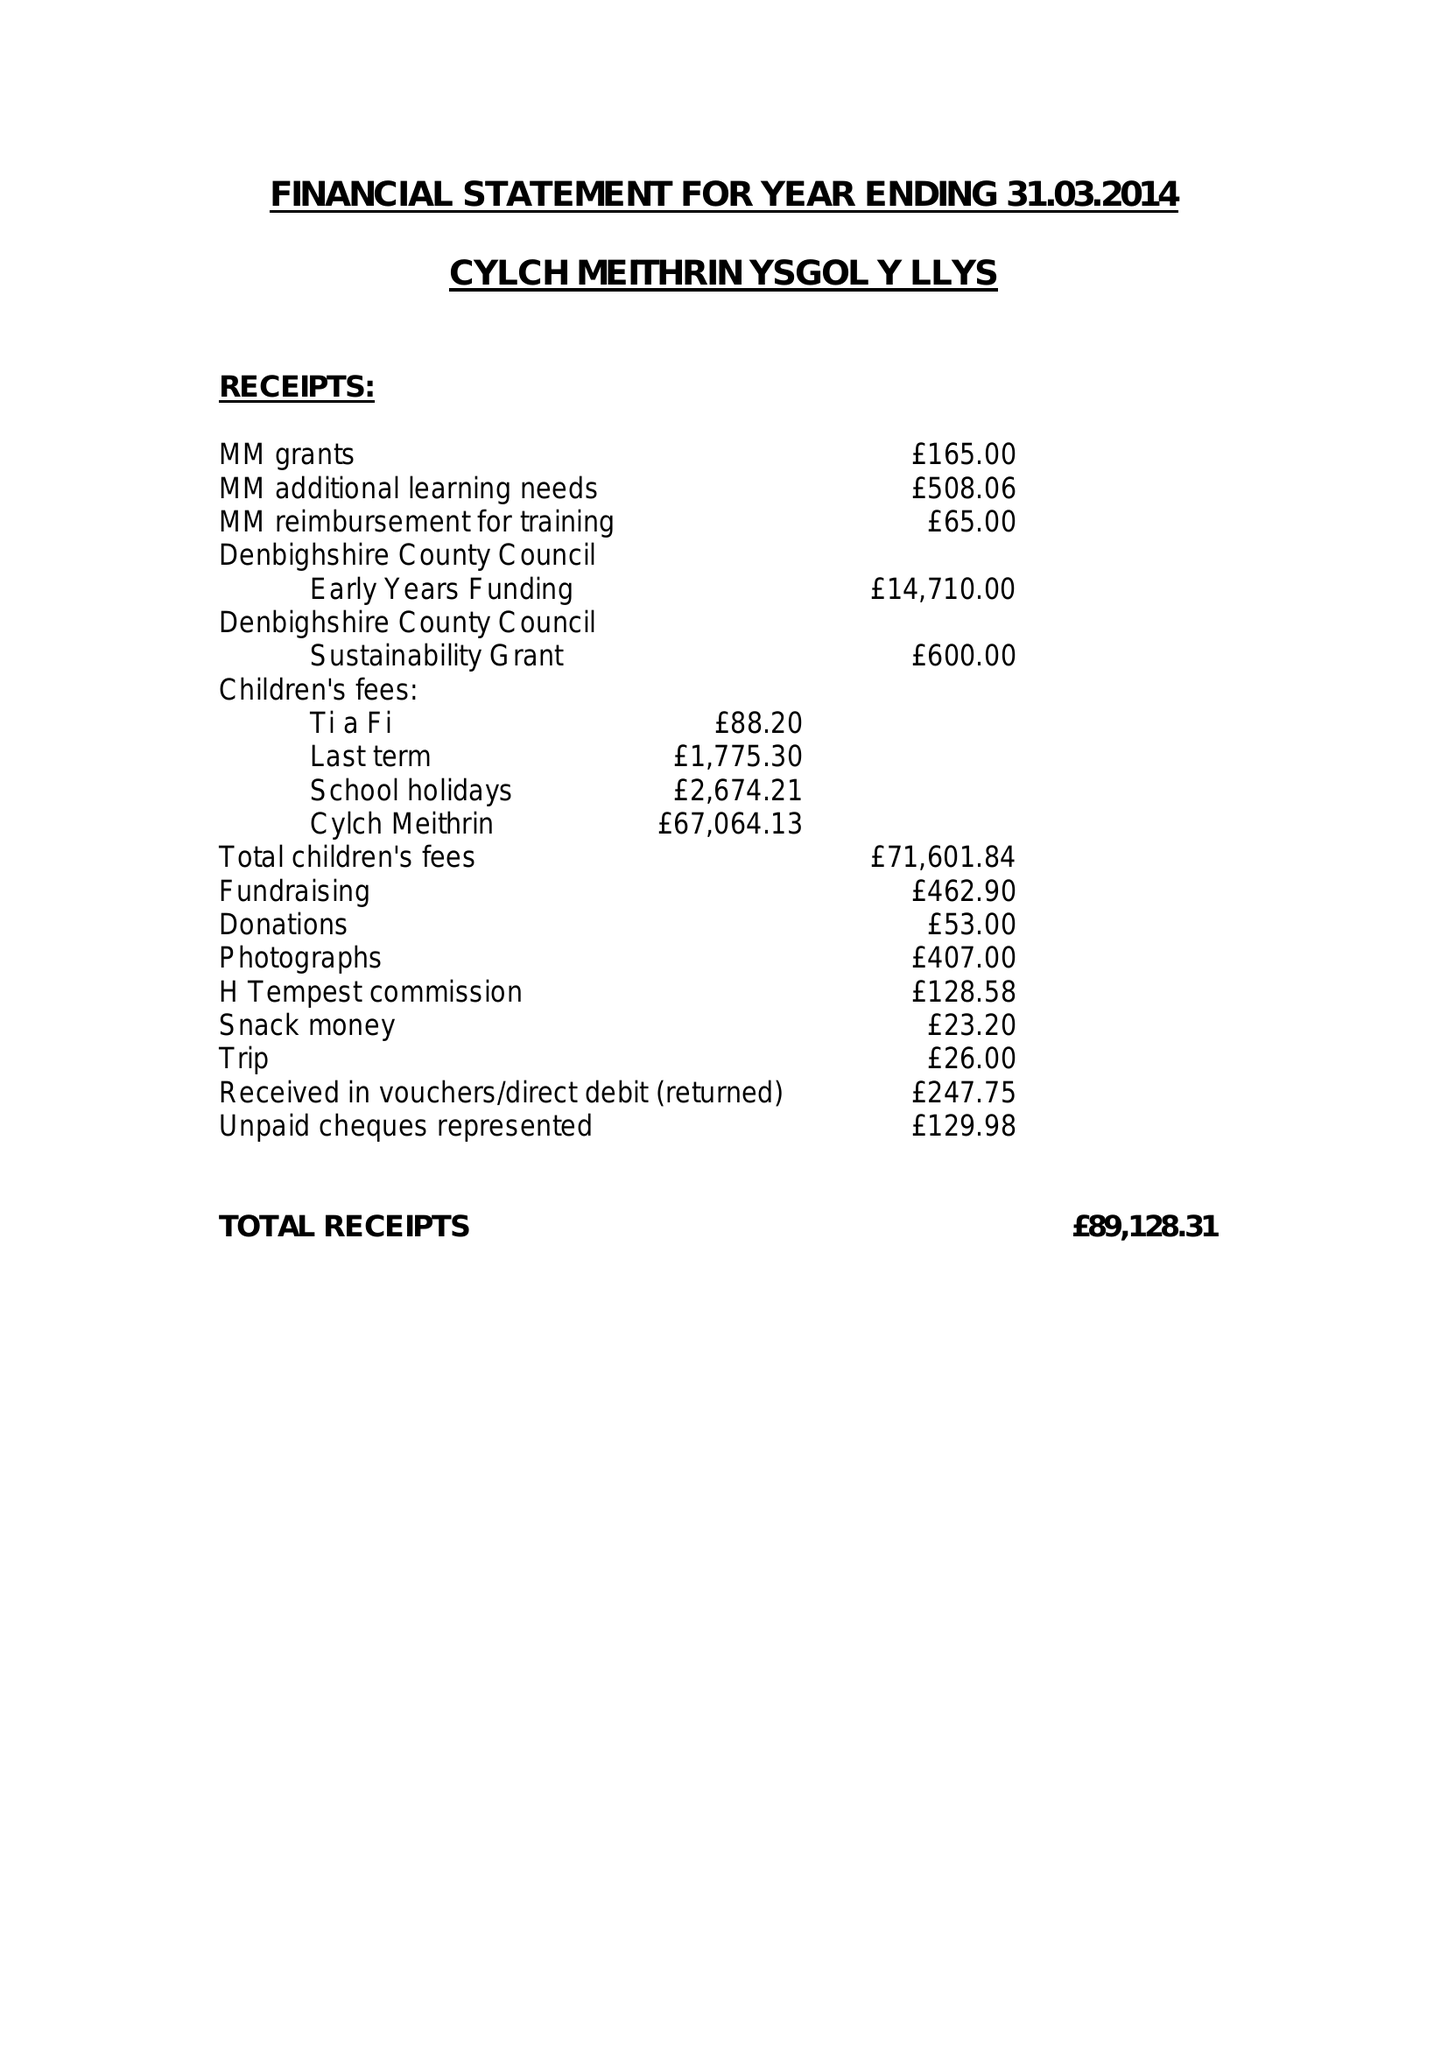What is the value for the spending_annually_in_british_pounds?
Answer the question using a single word or phrase. 79577.00 